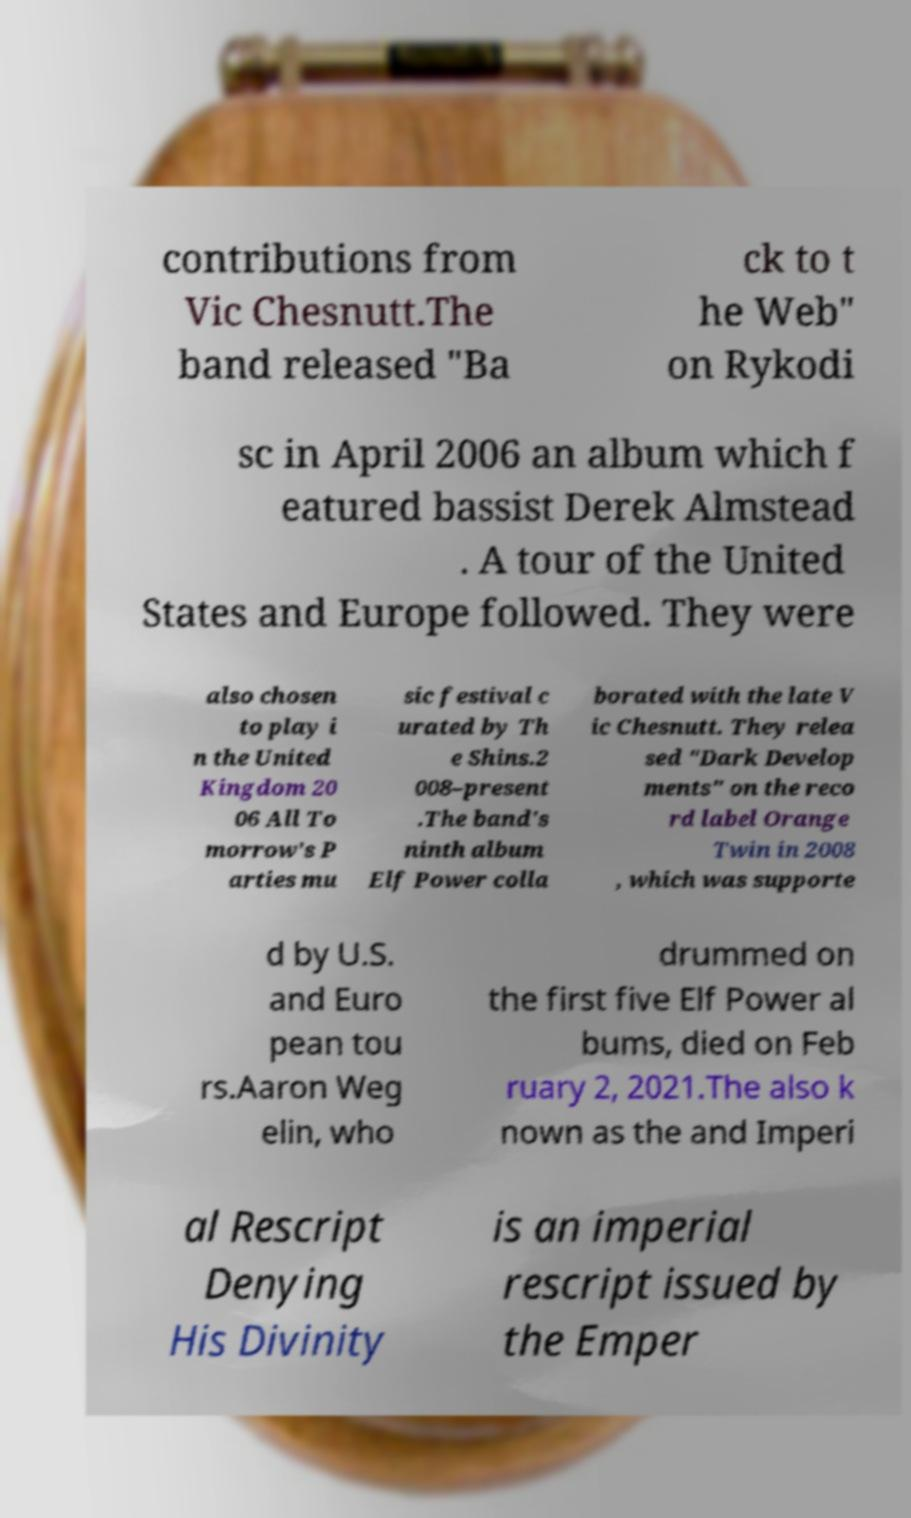There's text embedded in this image that I need extracted. Can you transcribe it verbatim? contributions from Vic Chesnutt.The band released "Ba ck to t he Web" on Rykodi sc in April 2006 an album which f eatured bassist Derek Almstead . A tour of the United States and Europe followed. They were also chosen to play i n the United Kingdom 20 06 All To morrow's P arties mu sic festival c urated by Th e Shins.2 008–present .The band's ninth album Elf Power colla borated with the late V ic Chesnutt. They relea sed "Dark Develop ments" on the reco rd label Orange Twin in 2008 , which was supporte d by U.S. and Euro pean tou rs.Aaron Weg elin, who drummed on the first five Elf Power al bums, died on Feb ruary 2, 2021.The also k nown as the and Imperi al Rescript Denying His Divinity is an imperial rescript issued by the Emper 